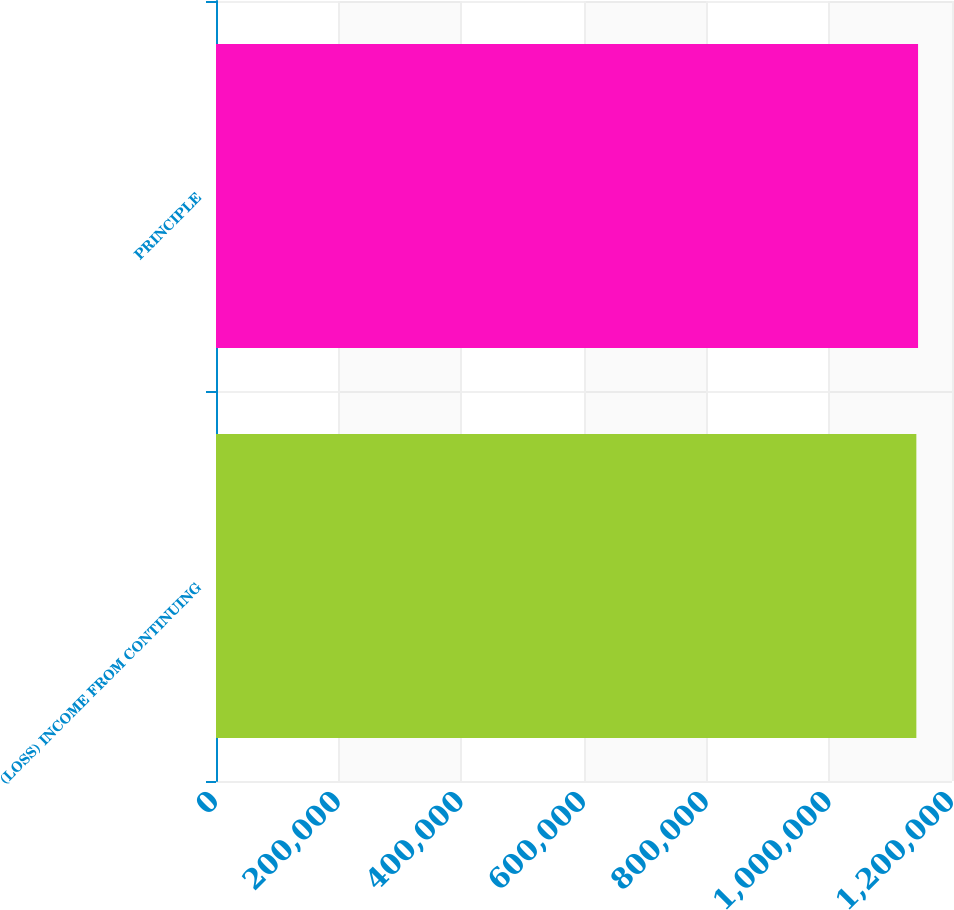<chart> <loc_0><loc_0><loc_500><loc_500><bar_chart><fcel>(LOSS) INCOME FROM CONTINUING<fcel>PRINCIPLE<nl><fcel>1.14188e+06<fcel>1.14465e+06<nl></chart> 